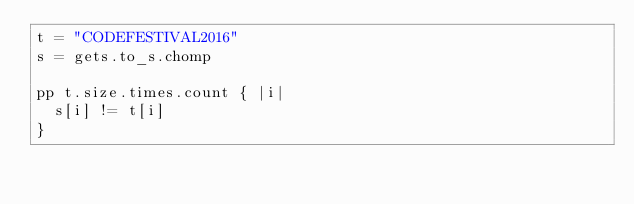<code> <loc_0><loc_0><loc_500><loc_500><_Crystal_>t = "CODEFESTIVAL2016"
s = gets.to_s.chomp

pp t.size.times.count { |i|
  s[i] != t[i]
}</code> 